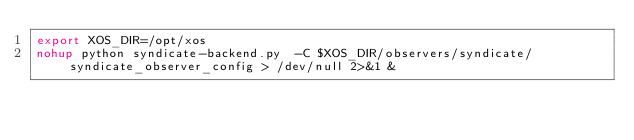<code> <loc_0><loc_0><loc_500><loc_500><_Bash_>export XOS_DIR=/opt/xos
nohup python syndicate-backend.py  -C $XOS_DIR/observers/syndicate/syndicate_observer_config > /dev/null 2>&1 &
</code> 